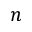Convert formula to latex. <formula><loc_0><loc_0><loc_500><loc_500>n</formula> 